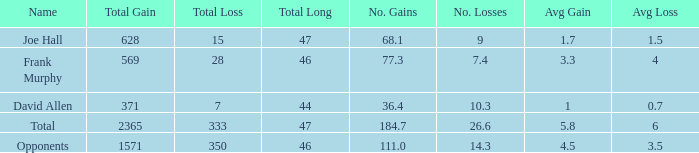How much Avg/G has a Gain smaller than 1571, and a Long smaller than 46? 1.0. Parse the table in full. {'header': ['Name', 'Total Gain', 'Total Loss', 'Total Long', 'No. Gains', 'No. Losses', 'Avg Gain', 'Avg Loss'], 'rows': [['Joe Hall', '628', '15', '47', '68.1', '9', '1.7', '1.5'], ['Frank Murphy', '569', '28', '46', '77.3', '7.4', '3.3', '4'], ['David Allen', '371', '7', '44', '36.4', '10.3', '1', '0.7'], ['Total', '2365', '333', '47', '184.7', '26.6', '5.8', '6'], ['Opponents', '1571', '350', '46', '111.0', '14.3', '4.5', '3.5']]} 